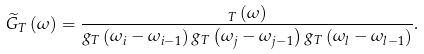Convert formula to latex. <formula><loc_0><loc_0><loc_500><loc_500>\widetilde { G } _ { T } \left ( \omega \right ) = \frac { _ { T } \left ( \omega \right ) } { g _ { T } \left ( \omega _ { i } - \omega _ { i - 1 } \right ) g _ { T } \left ( \omega _ { j } - \omega _ { j - 1 } \right ) g _ { T } \left ( \omega _ { l } - \omega _ { l - 1 } \right ) } .</formula> 